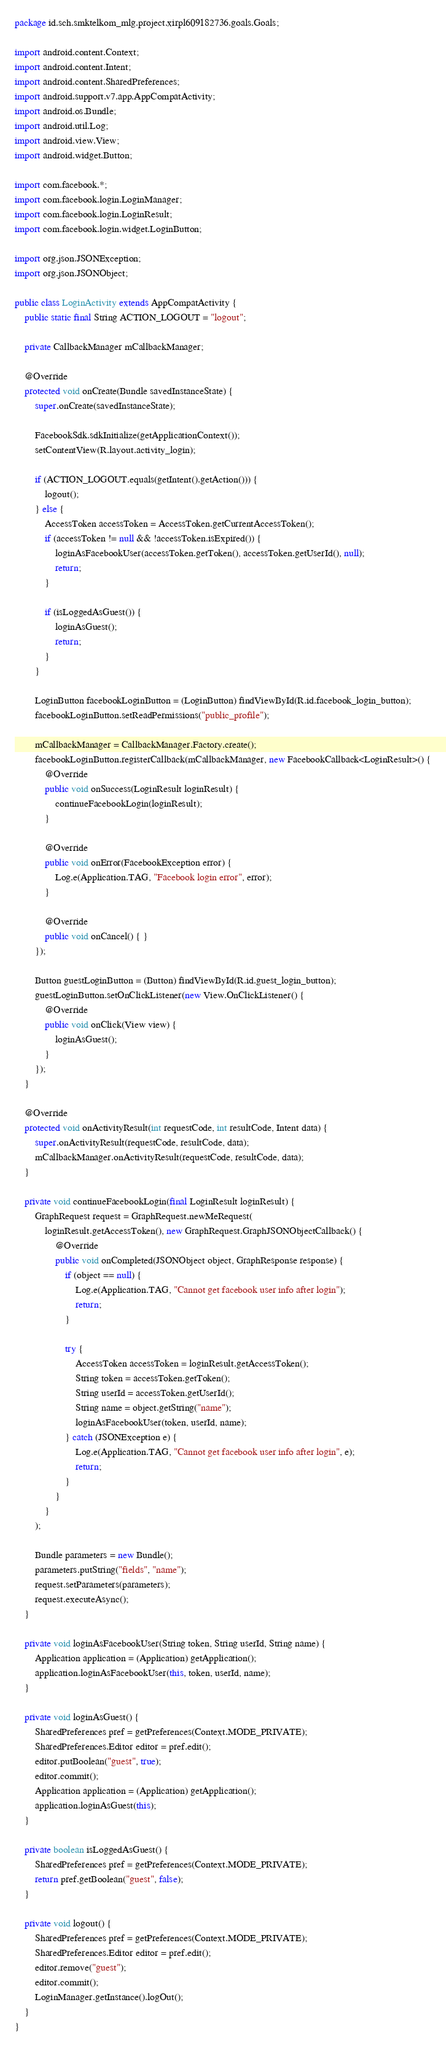<code> <loc_0><loc_0><loc_500><loc_500><_Java_>package id.sch.smktelkom_mlg.project.xirpl609182736.goals.Goals;

import android.content.Context;
import android.content.Intent;
import android.content.SharedPreferences;
import android.support.v7.app.AppCompatActivity;
import android.os.Bundle;
import android.util.Log;
import android.view.View;
import android.widget.Button;

import com.facebook.*;
import com.facebook.login.LoginManager;
import com.facebook.login.LoginResult;
import com.facebook.login.widget.LoginButton;

import org.json.JSONException;
import org.json.JSONObject;

public class LoginActivity extends AppCompatActivity {
    public static final String ACTION_LOGOUT = "logout";

    private CallbackManager mCallbackManager;

    @Override
    protected void onCreate(Bundle savedInstanceState) {
        super.onCreate(savedInstanceState);

        FacebookSdk.sdkInitialize(getApplicationContext());
        setContentView(R.layout.activity_login);

        if (ACTION_LOGOUT.equals(getIntent().getAction())) {
            logout();
        } else {
            AccessToken accessToken = AccessToken.getCurrentAccessToken();
            if (accessToken != null && !accessToken.isExpired()) {
                loginAsFacebookUser(accessToken.getToken(), accessToken.getUserId(), null);
                return;
            }

            if (isLoggedAsGuest()) {
                loginAsGuest();
                return;
            }
        }

        LoginButton facebookLoginButton = (LoginButton) findViewById(R.id.facebook_login_button);
        facebookLoginButton.setReadPermissions("public_profile");

        mCallbackManager = CallbackManager.Factory.create();
        facebookLoginButton.registerCallback(mCallbackManager, new FacebookCallback<LoginResult>() {
            @Override
            public void onSuccess(LoginResult loginResult) {
                continueFacebookLogin(loginResult);
            }

            @Override
            public void onError(FacebookException error) {
                Log.e(Application.TAG, "Facebook login error", error);
            }

            @Override
            public void onCancel() { }
        });

        Button guestLoginButton = (Button) findViewById(R.id.guest_login_button);
        guestLoginButton.setOnClickListener(new View.OnClickListener() {
            @Override
            public void onClick(View view) {
                loginAsGuest();
            }
        });
    }

    @Override
    protected void onActivityResult(int requestCode, int resultCode, Intent data) {
        super.onActivityResult(requestCode, resultCode, data);
        mCallbackManager.onActivityResult(requestCode, resultCode, data);
    }

    private void continueFacebookLogin(final LoginResult loginResult) {
        GraphRequest request = GraphRequest.newMeRequest(
            loginResult.getAccessToken(), new GraphRequest.GraphJSONObjectCallback() {
                @Override
                public void onCompleted(JSONObject object, GraphResponse response) {
                    if (object == null) {
                        Log.e(Application.TAG, "Cannot get facebook user info after login");
                        return;
                    }

                    try {
                        AccessToken accessToken = loginResult.getAccessToken();
                        String token = accessToken.getToken();
                        String userId = accessToken.getUserId();
                        String name = object.getString("name");
                        loginAsFacebookUser(token, userId, name);
                    } catch (JSONException e) {
                        Log.e(Application.TAG, "Cannot get facebook user info after login", e);
                        return;
                    }
                }
            }
        );

        Bundle parameters = new Bundle();
        parameters.putString("fields", "name");
        request.setParameters(parameters);
        request.executeAsync();
    }

    private void loginAsFacebookUser(String token, String userId, String name) {
        Application application = (Application) getApplication();
        application.loginAsFacebookUser(this, token, userId, name);
    }

    private void loginAsGuest() {
        SharedPreferences pref = getPreferences(Context.MODE_PRIVATE);
        SharedPreferences.Editor editor = pref.edit();
        editor.putBoolean("guest", true);
        editor.commit();
        Application application = (Application) getApplication();
        application.loginAsGuest(this);
    }

    private boolean isLoggedAsGuest() {
        SharedPreferences pref = getPreferences(Context.MODE_PRIVATE);
        return pref.getBoolean("guest", false);
    }

    private void logout() {
        SharedPreferences pref = getPreferences(Context.MODE_PRIVATE);
        SharedPreferences.Editor editor = pref.edit();
        editor.remove("guest");
        editor.commit();
        LoginManager.getInstance().logOut();
    }
}
</code> 